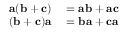Convert formula to latex. <formula><loc_0><loc_0><loc_500><loc_500>\begin{array} { r l } { a ( b + c ) } & = a b + a c } \\ { ( b + c ) a } & = b a + c a } \end{array}</formula> 